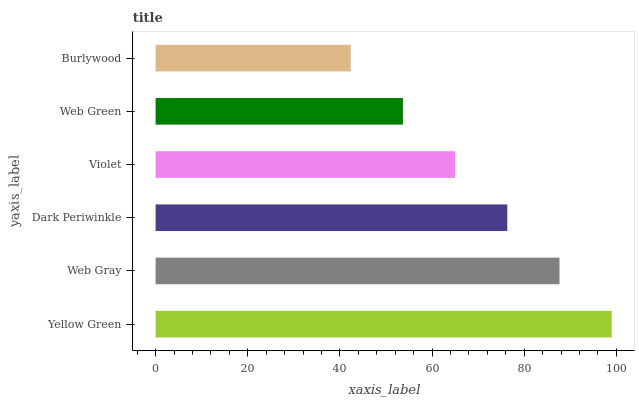Is Burlywood the minimum?
Answer yes or no. Yes. Is Yellow Green the maximum?
Answer yes or no. Yes. Is Web Gray the minimum?
Answer yes or no. No. Is Web Gray the maximum?
Answer yes or no. No. Is Yellow Green greater than Web Gray?
Answer yes or no. Yes. Is Web Gray less than Yellow Green?
Answer yes or no. Yes. Is Web Gray greater than Yellow Green?
Answer yes or no. No. Is Yellow Green less than Web Gray?
Answer yes or no. No. Is Dark Periwinkle the high median?
Answer yes or no. Yes. Is Violet the low median?
Answer yes or no. Yes. Is Violet the high median?
Answer yes or no. No. Is Dark Periwinkle the low median?
Answer yes or no. No. 